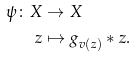<formula> <loc_0><loc_0><loc_500><loc_500>\psi \colon X & \to X \\ z & \mapsto g _ { v ( z ) } * z .</formula> 